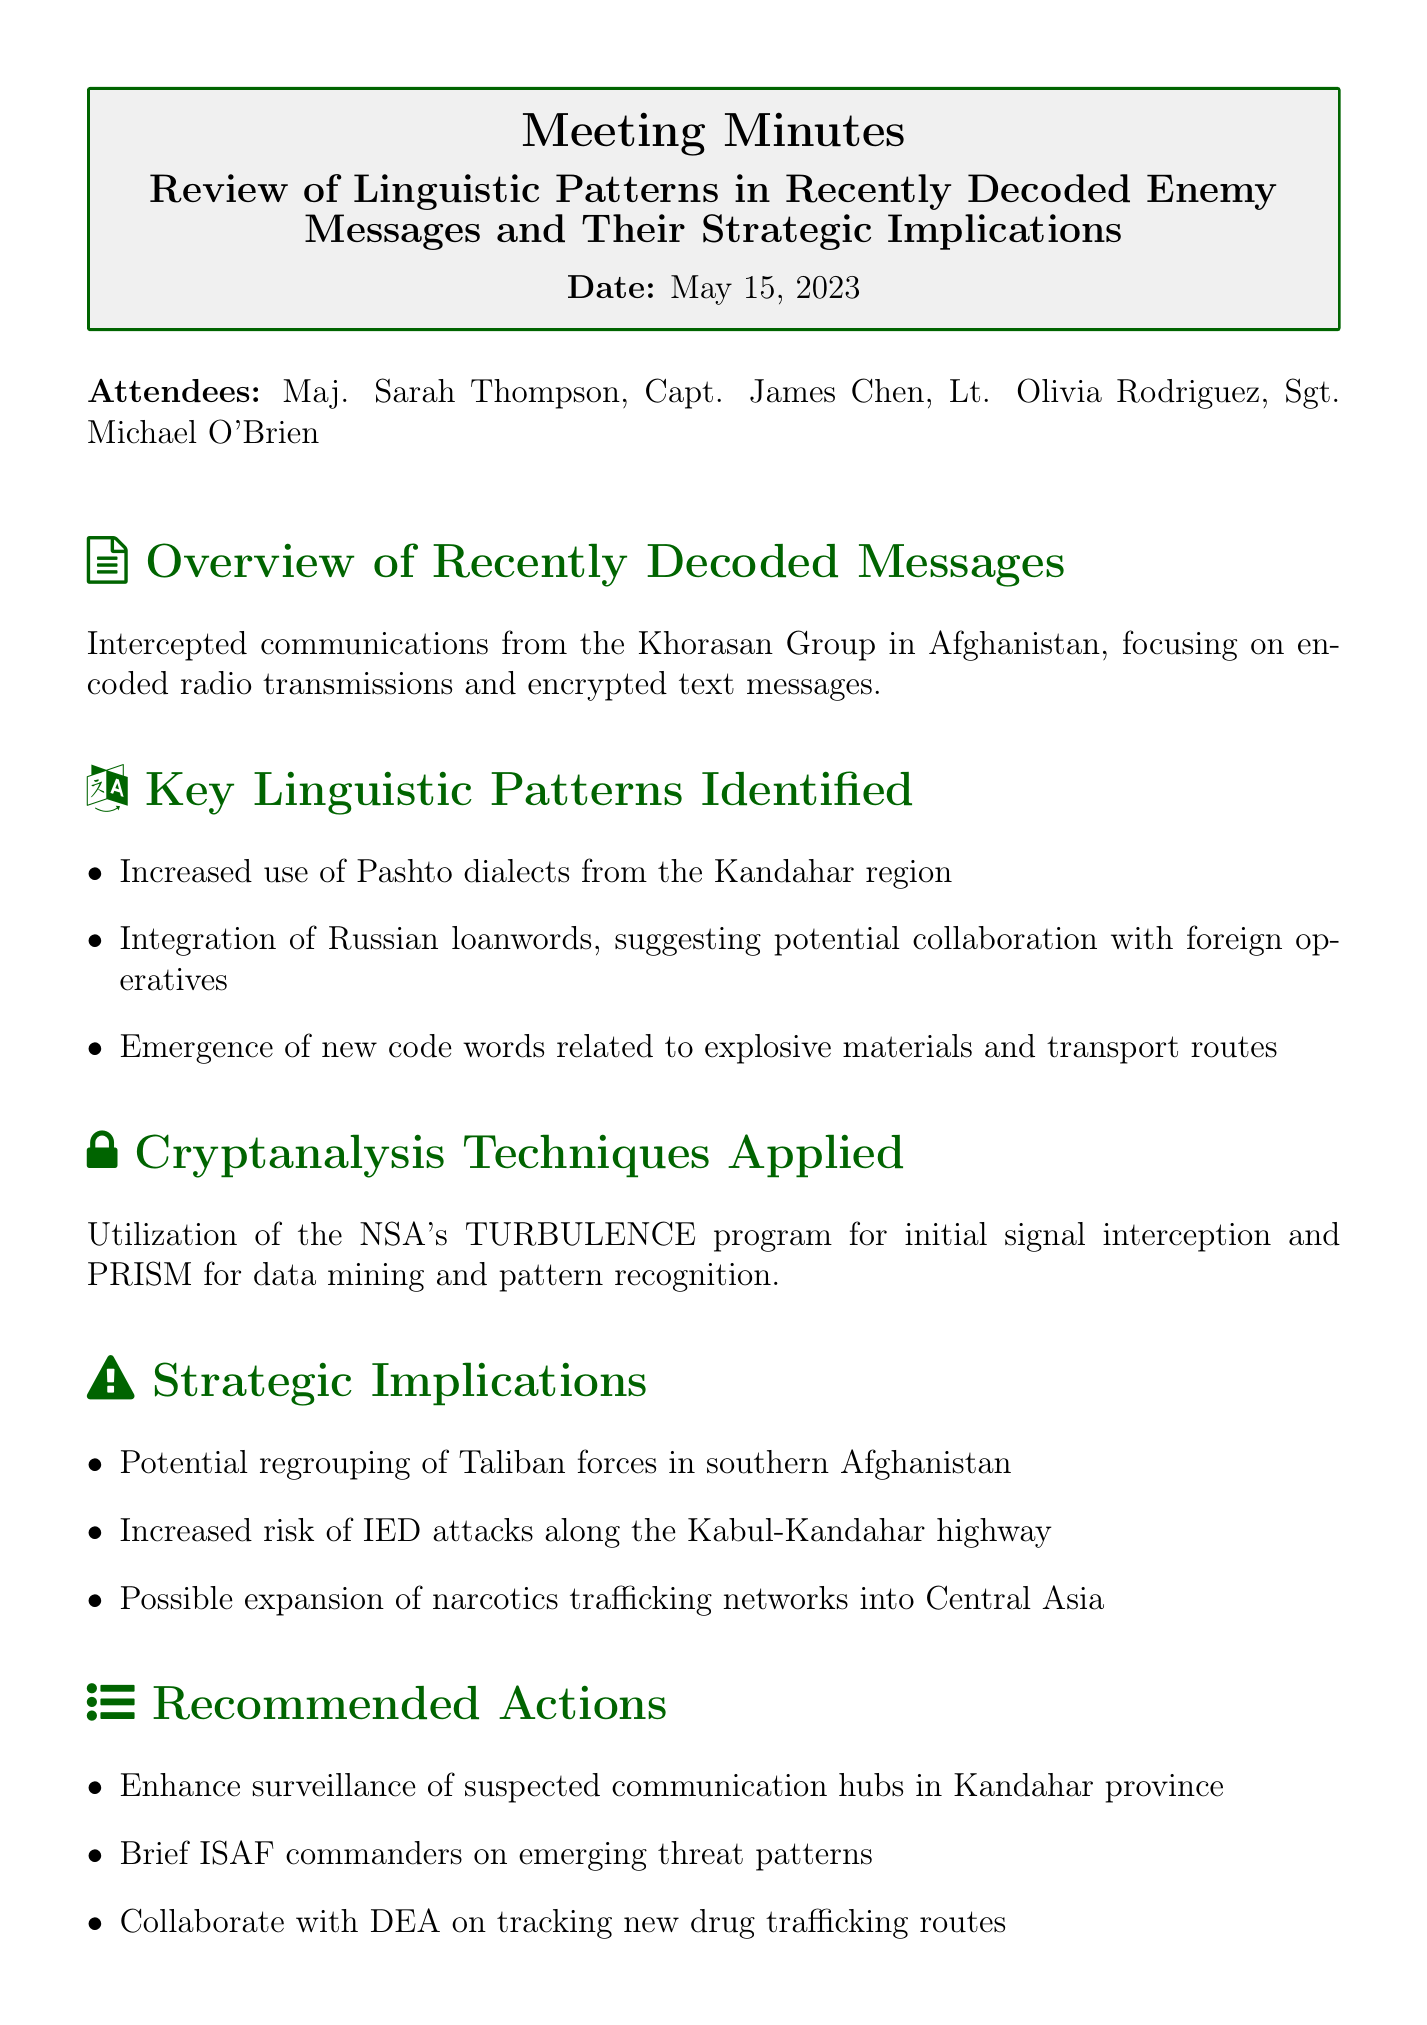What is the meeting title? The meeting title is specified at the beginning of the document, describing the focus on linguistic patterns in enemy communications.
Answer: Review of Linguistic Patterns in Recently Decoded Enemy Messages and Their Strategic Implications Who was the first attendee listed? The first attendee is mentioned in the list of participants, highlighting their role in the meeting.
Answer: Maj. Sarah Thompson What date was the meeting held? The date is clearly indicated in the document, marking when the review took place.
Answer: May 15, 2023 What dialect is noted to have increased use in the decoded messages? A specific linguistic feature is identified in the key patterns section, referencing regional language use.
Answer: Pashto dialects What program was used for initial signal interception? This information comes from the cryptanalysis techniques section, detailing the methodologies employed for decoding.
Answer: NSA's TURBULENCE program What strategic implication is associated with IED attacks? This aspect reflects the risks identified during the discussions regarding potential threats based on the decoded messages.
Answer: Increased risk of IED attacks along the Kabul-Kandahar highway What recommended action involves DEA collaboration? Listed in the recommended actions section, this collaboration targets an emerging issue reflected in the decoded communication patterns.
Answer: Collaborate with DEA on tracking new drug trafficking routes How many attendees were present at the meeting? This is a straightforward piece of information derived from the attendees list provided at the start of the document.
Answer: Four 